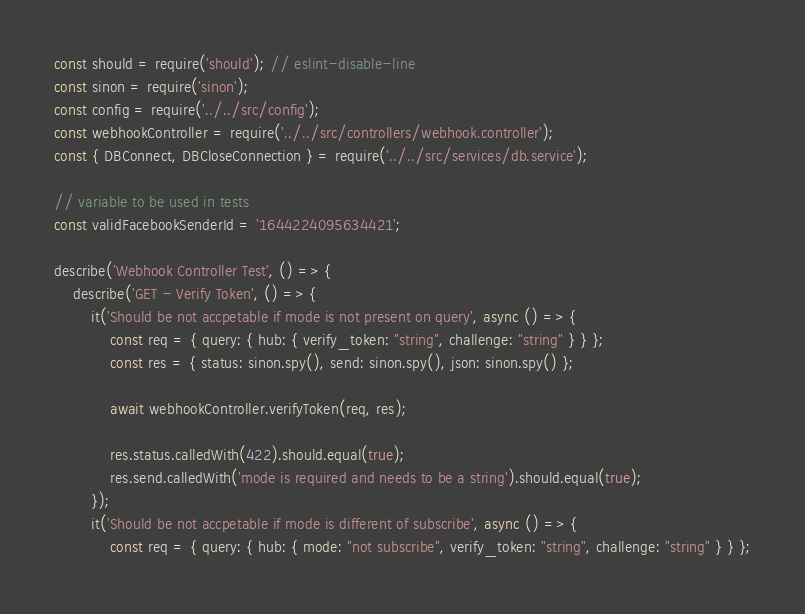Convert code to text. <code><loc_0><loc_0><loc_500><loc_500><_JavaScript_>const should = require('should'); // eslint-disable-line
const sinon = require('sinon');
const config = require('../../src/config');
const webhookController = require('../../src/controllers/webhook.controller');
const { DBConnect, DBCloseConnection } = require('../../src/services/db.service');

// variable to be used in tests
const validFacebookSenderId = '1644224095634421';

describe('Webhook Controller Test', () => {
    describe('GET - Verify Token', () => {
        it('Should be not accpetable if mode is not present on query', async () => {
            const req = { query: { hub: { verify_token: "string", challenge: "string" } } };
            const res = { status: sinon.spy(), send: sinon.spy(), json: sinon.spy() };

            await webhookController.verifyToken(req, res);

            res.status.calledWith(422).should.equal(true);
            res.send.calledWith('mode is required and needs to be a string').should.equal(true);
        });
        it('Should be not accpetable if mode is different of subscribe', async () => {
            const req = { query: { hub: { mode: "not subscribe", verify_token: "string", challenge: "string" } } };</code> 